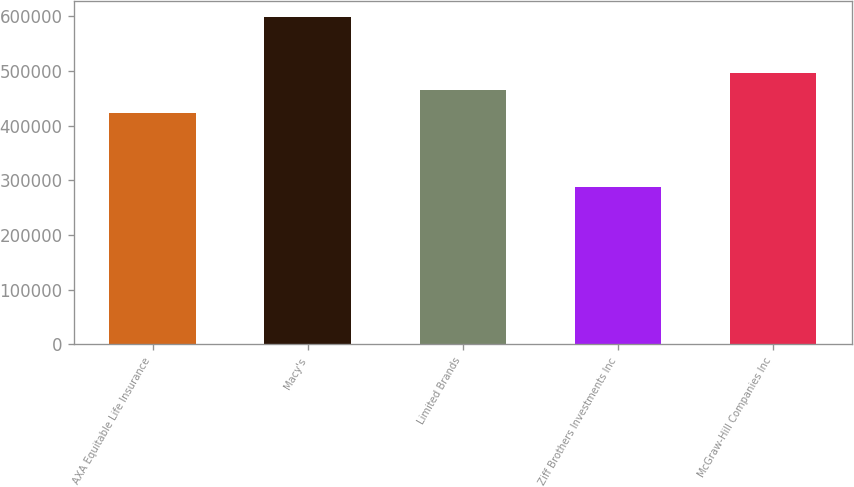Convert chart. <chart><loc_0><loc_0><loc_500><loc_500><bar_chart><fcel>AXA Equitable Life Insurance<fcel>Macy's<fcel>Limited Brands<fcel>Ziff Brothers Investments Inc<fcel>McGraw-Hill Companies Inc<nl><fcel>423000<fcel>598000<fcel>465000<fcel>287000<fcel>496100<nl></chart> 